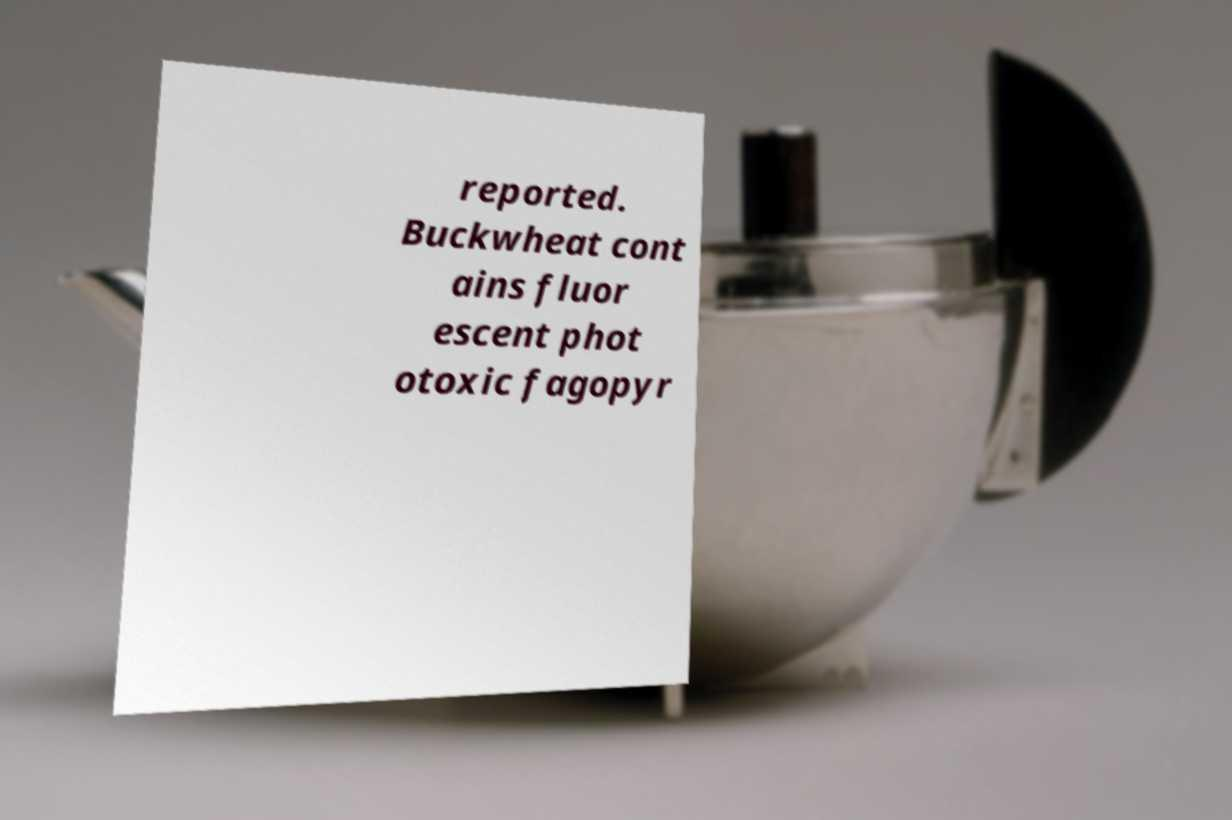Can you accurately transcribe the text from the provided image for me? reported. Buckwheat cont ains fluor escent phot otoxic fagopyr 